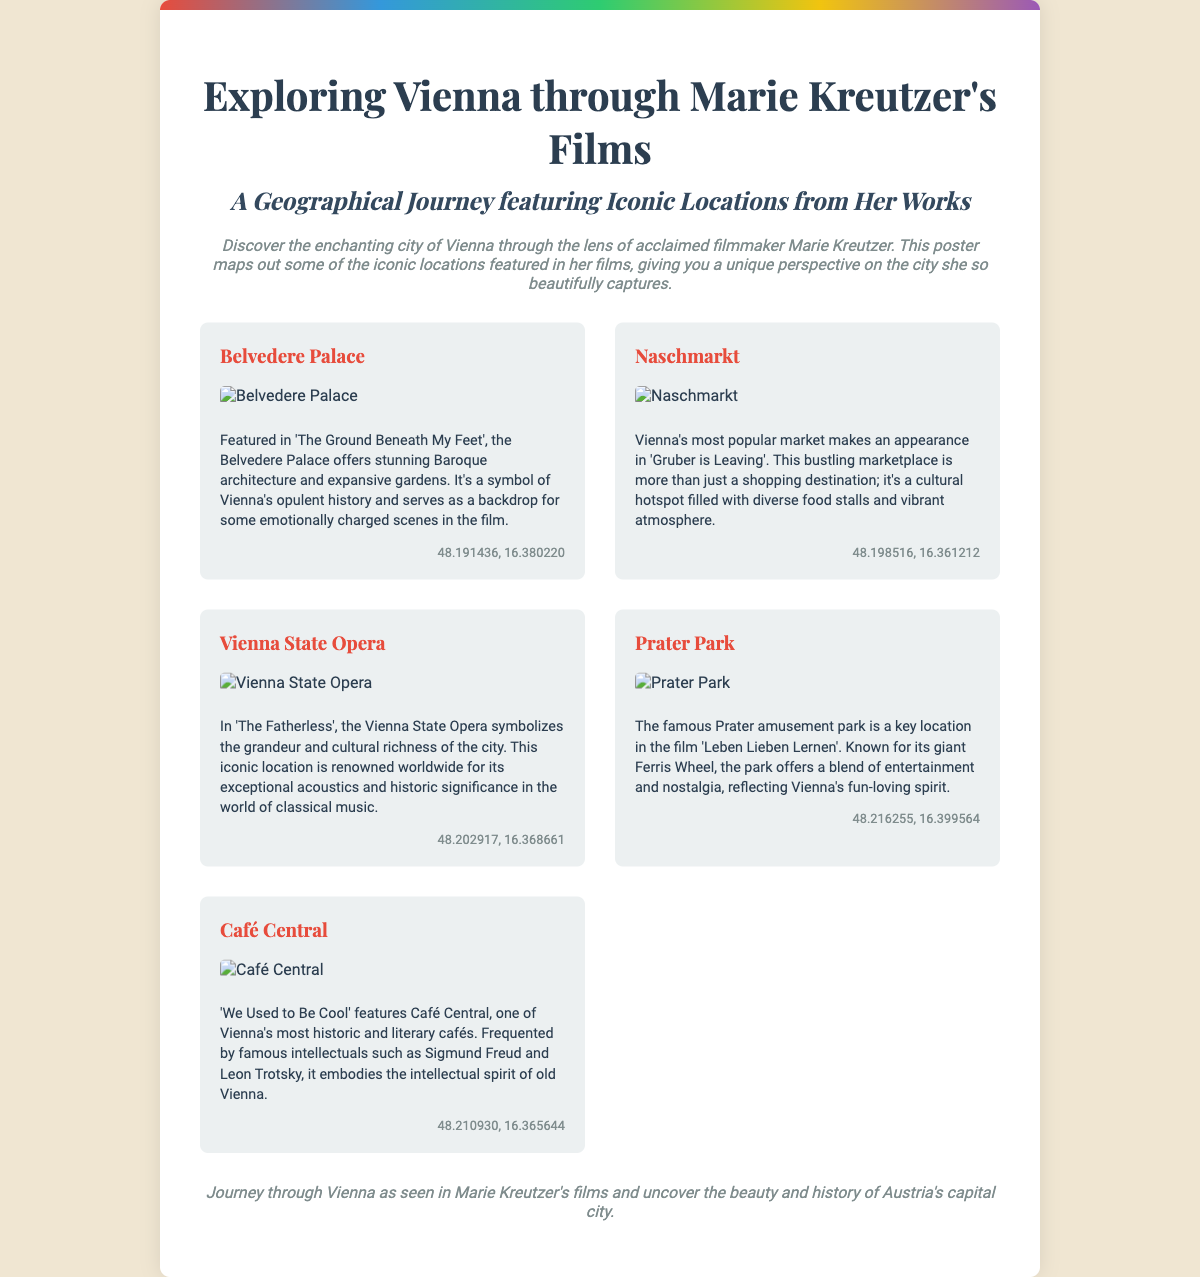What is the title of the poster? The title of the poster is prominently displayed at the top, indicating the focus of the content.
Answer: Exploring Vienna through Marie Kreutzer's Films How many locations are featured on the poster? The poster showcases a total of five iconic locations from Marie Kreutzer's films.
Answer: 5 Which film features the Belvedere Palace? The specific film that includes the Belvedere Palace is mentioned in the description of that location.
Answer: The Ground Beneath My Feet What type of architecture does the Belvedere Palace represent? The description of the Belvedere Palace cites its architectural style, which is a key feature of the site.
Answer: Baroque What is located at the coordinates 48.198516, 16.361212? The coordinates are linked to a specific location presented on the poster, highlighting its geographical significance.
Answer: Naschmarkt Which café is associated with famous intellectuals? The description of this location references its historical ties to notable figures, emphasizing its cultural importance.
Answer: Café Central What is the iconic attraction at Prater Park? The description of Prater Park mentions a well-known feature that characterizes the amusement park.
Answer: Giant Ferris Wheel Which film depicts the Vienna State Opera? The poster connects the Vienna State Opera to a particular film, outlining its role in Kreutzer's work.
Answer: The Fatherless 